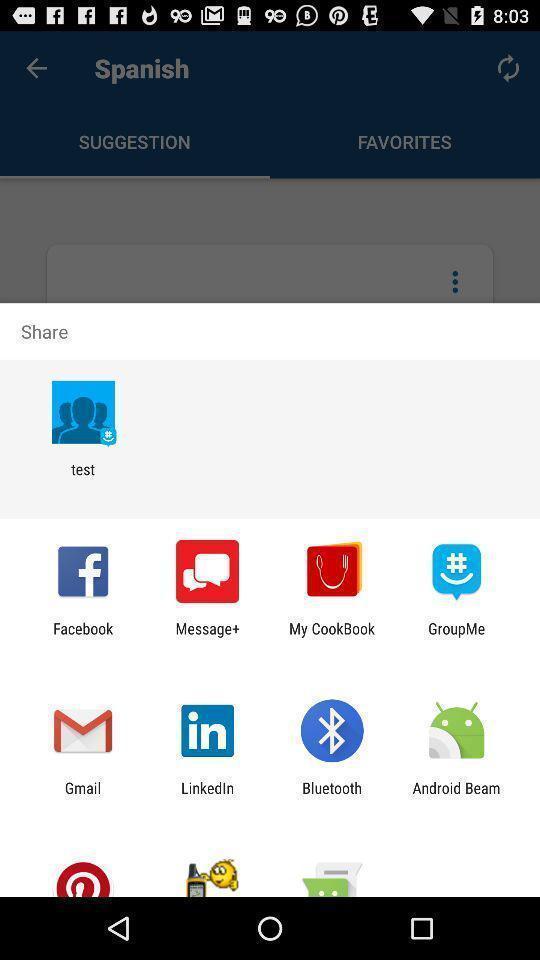Provide a detailed account of this screenshot. Pop up of sharing data with different social media. 